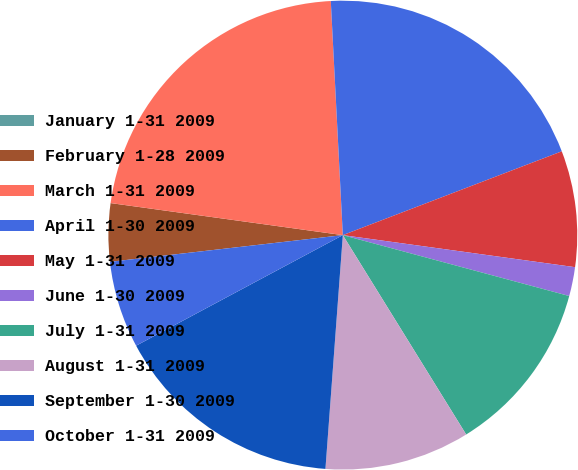<chart> <loc_0><loc_0><loc_500><loc_500><pie_chart><fcel>January 1-31 2009<fcel>February 1-28 2009<fcel>March 1-31 2009<fcel>April 1-30 2009<fcel>May 1-31 2009<fcel>June 1-30 2009<fcel>July 1-31 2009<fcel>August 1-31 2009<fcel>September 1-30 2009<fcel>October 1-31 2009<nl><fcel>0.0%<fcel>4.0%<fcel>22.0%<fcel>20.0%<fcel>8.0%<fcel>2.0%<fcel>12.0%<fcel>10.0%<fcel>16.0%<fcel>6.0%<nl></chart> 